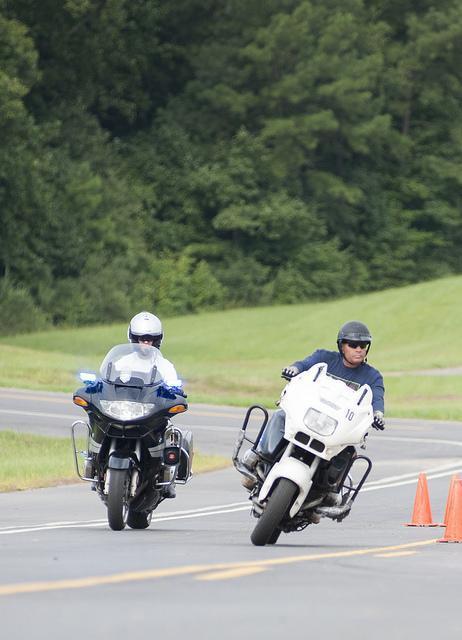How many motorcycles are in the picture?
Give a very brief answer. 2. How many people are there?
Give a very brief answer. 2. 